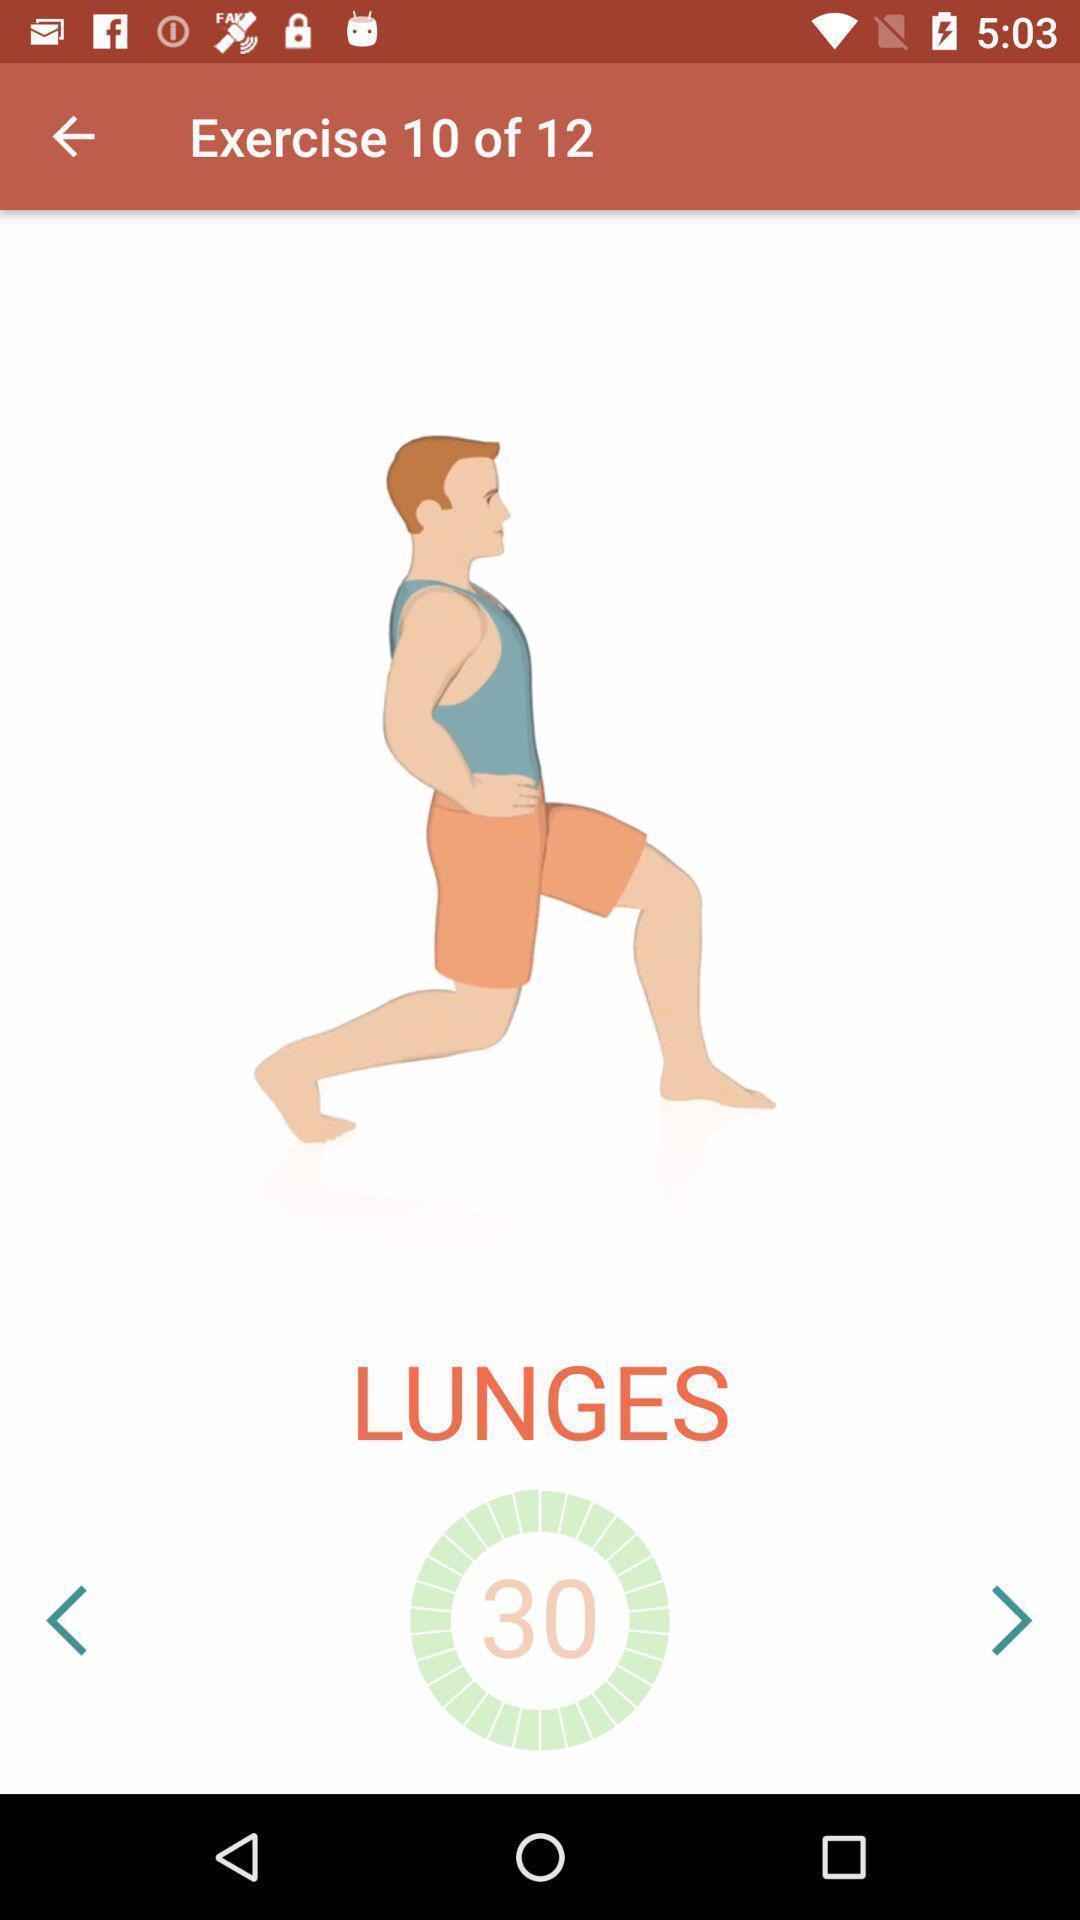Summarize the information in this screenshot. Workout page displayed of fitness training app. 